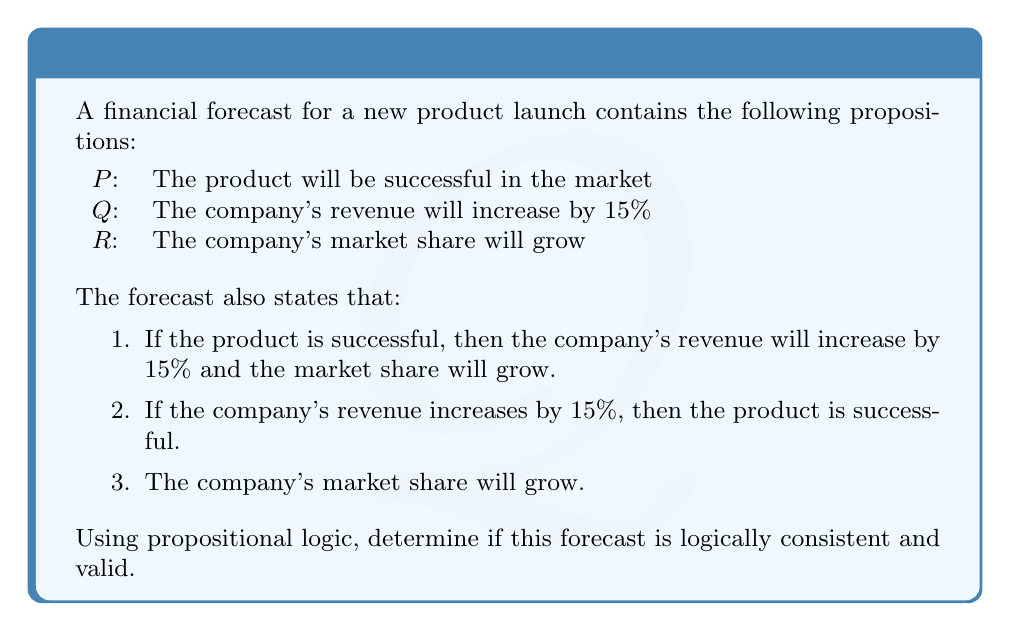Show me your answer to this math problem. To evaluate the validity of this financial forecast using propositional logic, we need to translate the given statements into logical expressions and then analyze their consistency.

Let's translate the statements:

1. $P \rightarrow (Q \wedge R)$
2. $Q \rightarrow P$
3. $R$

Now, let's analyze the logical consistency:

1. We start with the given fact that R is true.

2. From statement 1, we have $P \rightarrow (Q \wedge R)$. This means that if P is true, then both Q and R must be true.

3. From statement 2, we have $Q \rightarrow P$. This means that if Q is true, then P must be true.

4. We don't have any direct information about the truth value of P or Q.

5. Let's consider both possibilities for P:

   Case 1: If P is true
   - From statement 1, Q must also be true (since R is already true)
   - This is consistent with statement 2

   Case 2: If P is false
   - From statement 2, Q must also be false
   - This is consistent with statement 1

6. In both cases, we don't encounter any contradictions. This means the set of propositions is logically consistent.

7. To check validity, we need to see if the conclusion (R) necessarily follows from the premises. In this case, R is given as a standalone true statement, so it's valid regardless of the truth values of P and Q.

Therefore, the forecast is logically consistent and valid. There are no contradictions in the logical structure, and the conclusion (market share growth) is supported by the given statements.
Answer: The financial forecast is logically consistent and valid. 